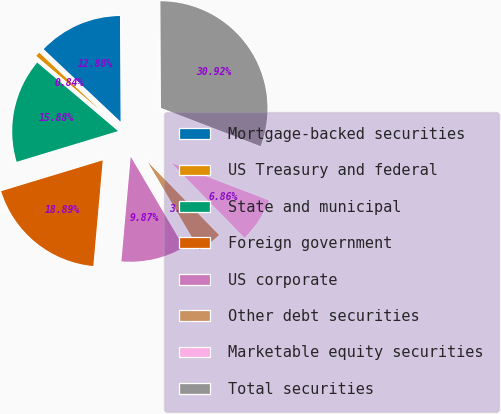<chart> <loc_0><loc_0><loc_500><loc_500><pie_chart><fcel>Mortgage-backed securities<fcel>US Treasury and federal<fcel>State and municipal<fcel>Foreign government<fcel>US corporate<fcel>Other debt securities<fcel>Marketable equity securities<fcel>Total securities<nl><fcel>12.88%<fcel>0.84%<fcel>15.88%<fcel>18.89%<fcel>9.87%<fcel>3.85%<fcel>6.86%<fcel>30.92%<nl></chart> 